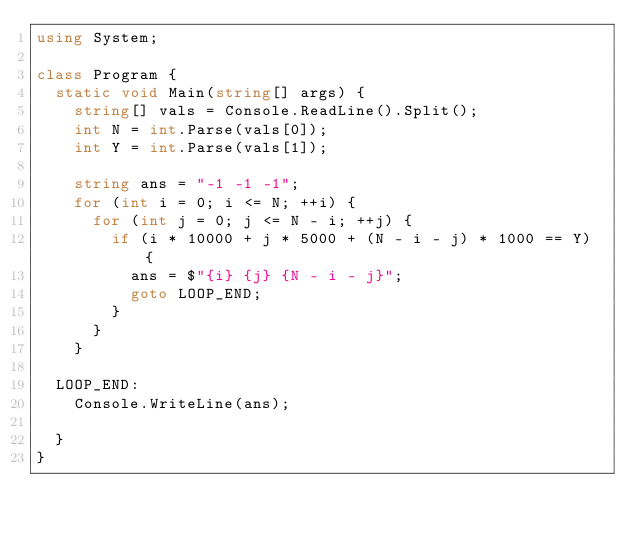<code> <loc_0><loc_0><loc_500><loc_500><_C#_>using System;

class Program {
  static void Main(string[] args) {
    string[] vals = Console.ReadLine().Split();
    int N = int.Parse(vals[0]);
    int Y = int.Parse(vals[1]);

    string ans = "-1 -1 -1";
    for (int i = 0; i <= N; ++i) {
      for (int j = 0; j <= N - i; ++j) {
        if (i * 10000 + j * 5000 + (N - i - j) * 1000 == Y) {
          ans = $"{i} {j} {N - i - j}";
          goto LOOP_END;
        }
      }
    }

  LOOP_END:
    Console.WriteLine(ans);

  }
}
</code> 